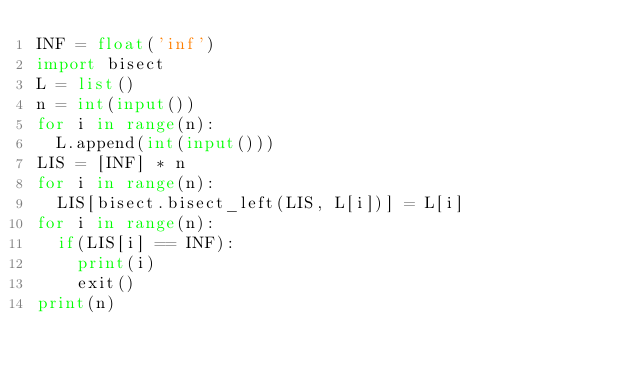<code> <loc_0><loc_0><loc_500><loc_500><_Python_>INF = float('inf')
import bisect
L = list()
n = int(input())
for i in range(n):
  L.append(int(input()))
LIS = [INF] * n
for i in range(n):
  LIS[bisect.bisect_left(LIS, L[i])] = L[i]
for i in range(n):
  if(LIS[i] == INF):
    print(i)
    exit()
print(n)
</code> 